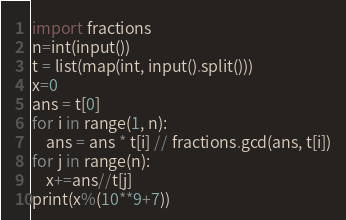Convert code to text. <code><loc_0><loc_0><loc_500><loc_500><_Python_>import fractions
n=int(input())
t = list(map(int, input().split()))
x=0
ans = t[0]
for i in range(1, n):
    ans = ans * t[i] // fractions.gcd(ans, t[i])
for j in range(n):
    x+=ans//t[j]
print(x%(10**9+7))</code> 